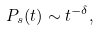<formula> <loc_0><loc_0><loc_500><loc_500>P _ { s } ( t ) \sim t ^ { - \delta } ,</formula> 